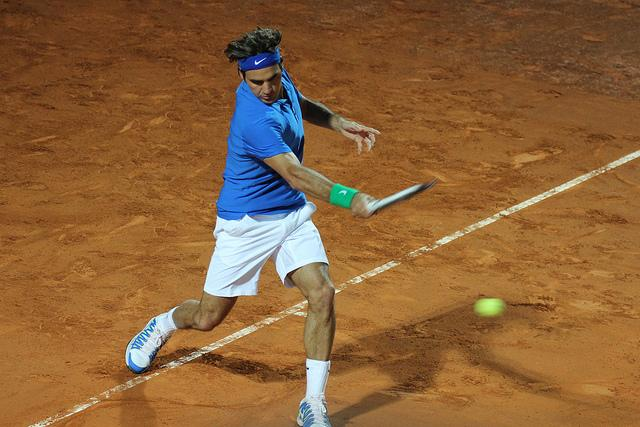What is the man wearing? shorts 